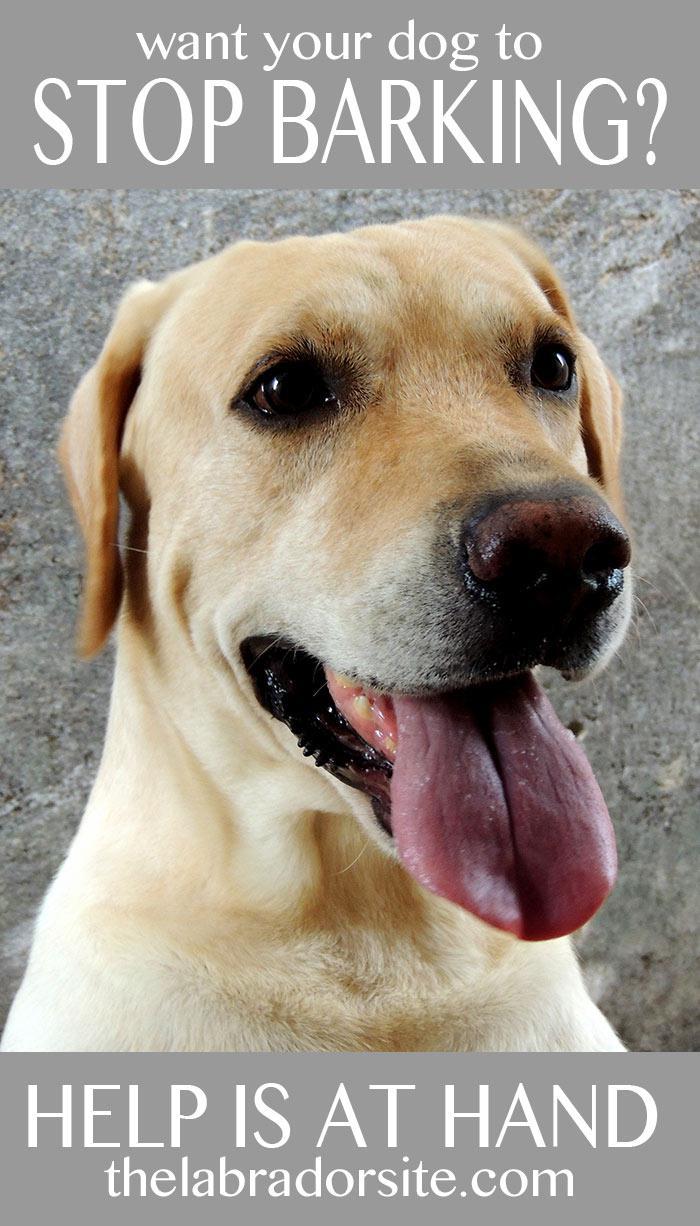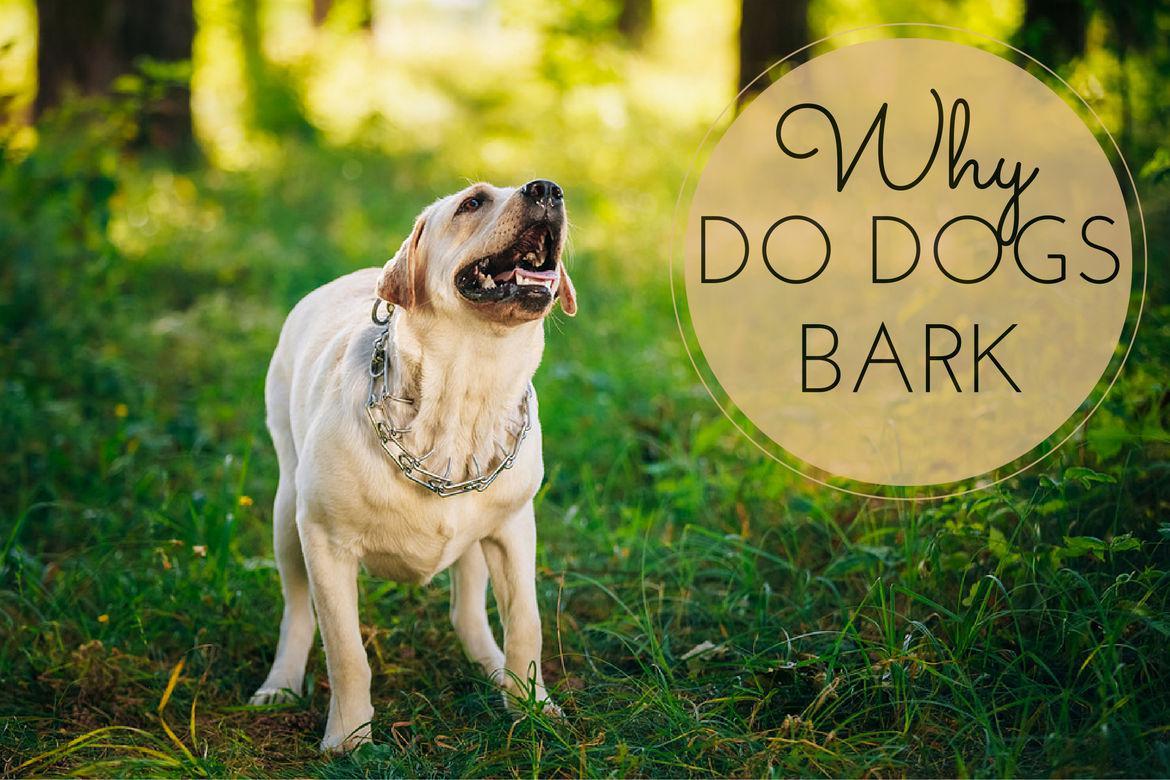The first image is the image on the left, the second image is the image on the right. For the images displayed, is the sentence "Only one image shows a dog with mouth opened." factually correct? Answer yes or no. No. The first image is the image on the left, the second image is the image on the right. For the images displayed, is the sentence "The dog on the right is on the grass." factually correct? Answer yes or no. Yes. 